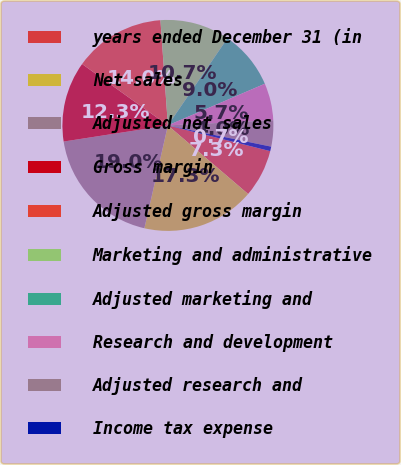Convert chart. <chart><loc_0><loc_0><loc_500><loc_500><pie_chart><fcel>years ended December 31 (in<fcel>Net sales<fcel>Adjusted net sales<fcel>Gross margin<fcel>Adjusted gross margin<fcel>Marketing and administrative<fcel>Adjusted marketing and<fcel>Research and development<fcel>Adjusted research and<fcel>Income tax expense<nl><fcel>7.34%<fcel>17.32%<fcel>18.98%<fcel>12.33%<fcel>13.99%<fcel>10.67%<fcel>9.0%<fcel>5.68%<fcel>4.01%<fcel>0.69%<nl></chart> 